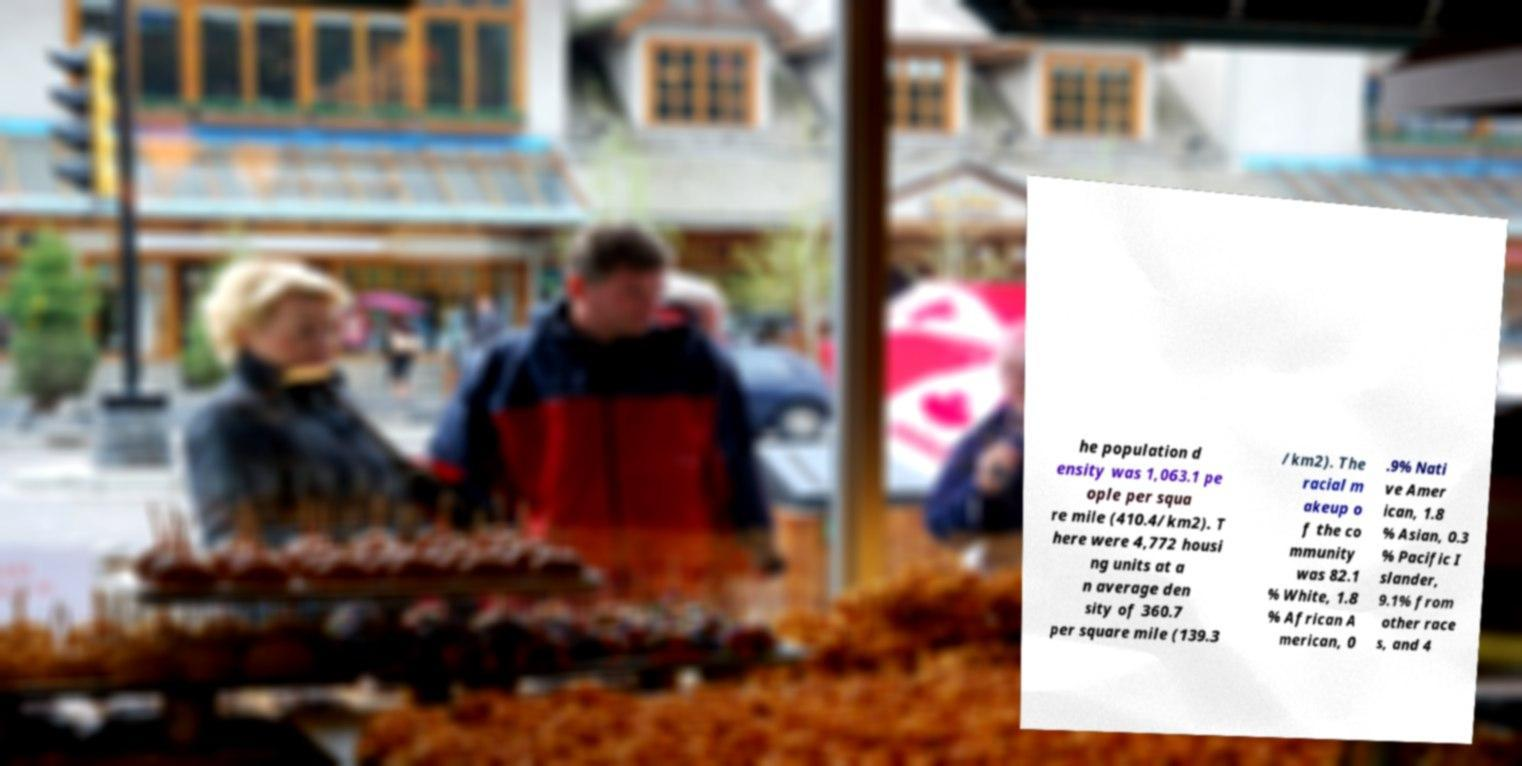Please read and relay the text visible in this image. What does it say? he population d ensity was 1,063.1 pe ople per squa re mile (410.4/km2). T here were 4,772 housi ng units at a n average den sity of 360.7 per square mile (139.3 /km2). The racial m akeup o f the co mmunity was 82.1 % White, 1.8 % African A merican, 0 .9% Nati ve Amer ican, 1.8 % Asian, 0.3 % Pacific I slander, 9.1% from other race s, and 4 